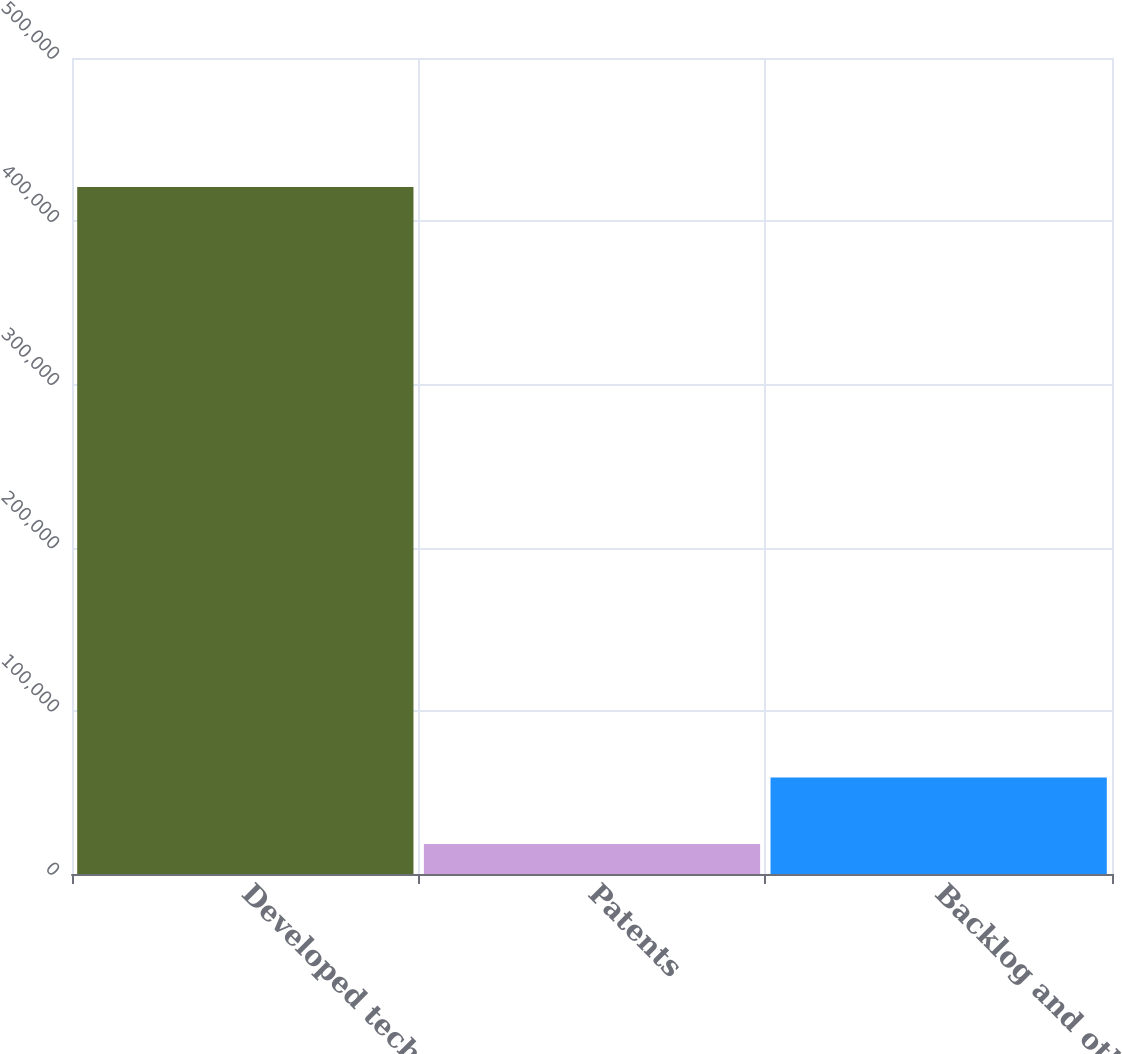Convert chart to OTSL. <chart><loc_0><loc_0><loc_500><loc_500><bar_chart><fcel>Developed technology<fcel>Patents<fcel>Backlog and other<nl><fcel>420887<fcel>18416<fcel>59127<nl></chart> 